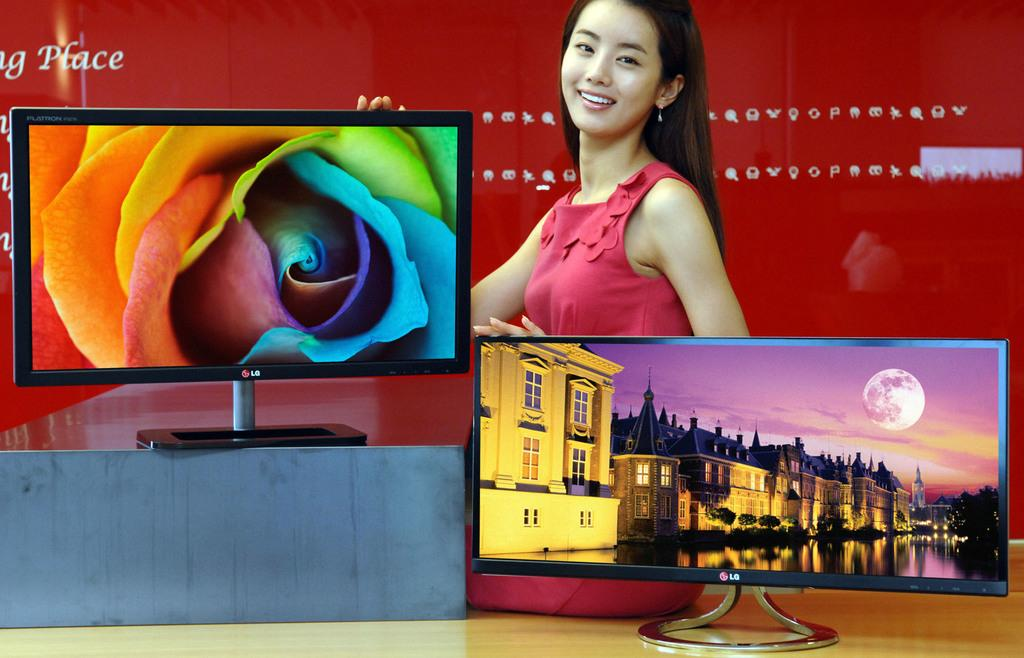<image>
Describe the image concisely. The word place can be seen to the left of a woman and two televisions. 